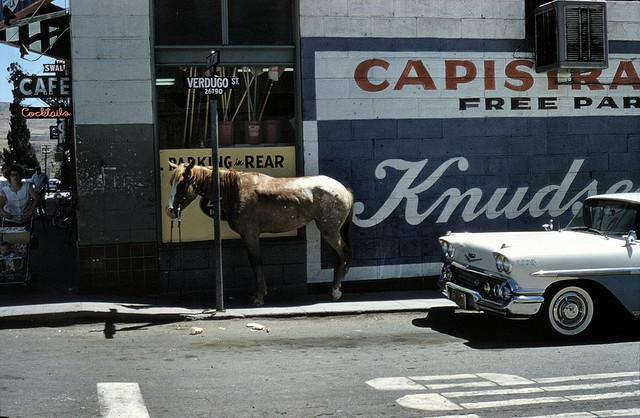This animal is frequently used as transportation by what profession? Please explain your reasoning. police officer. The animal is with the police officer. 